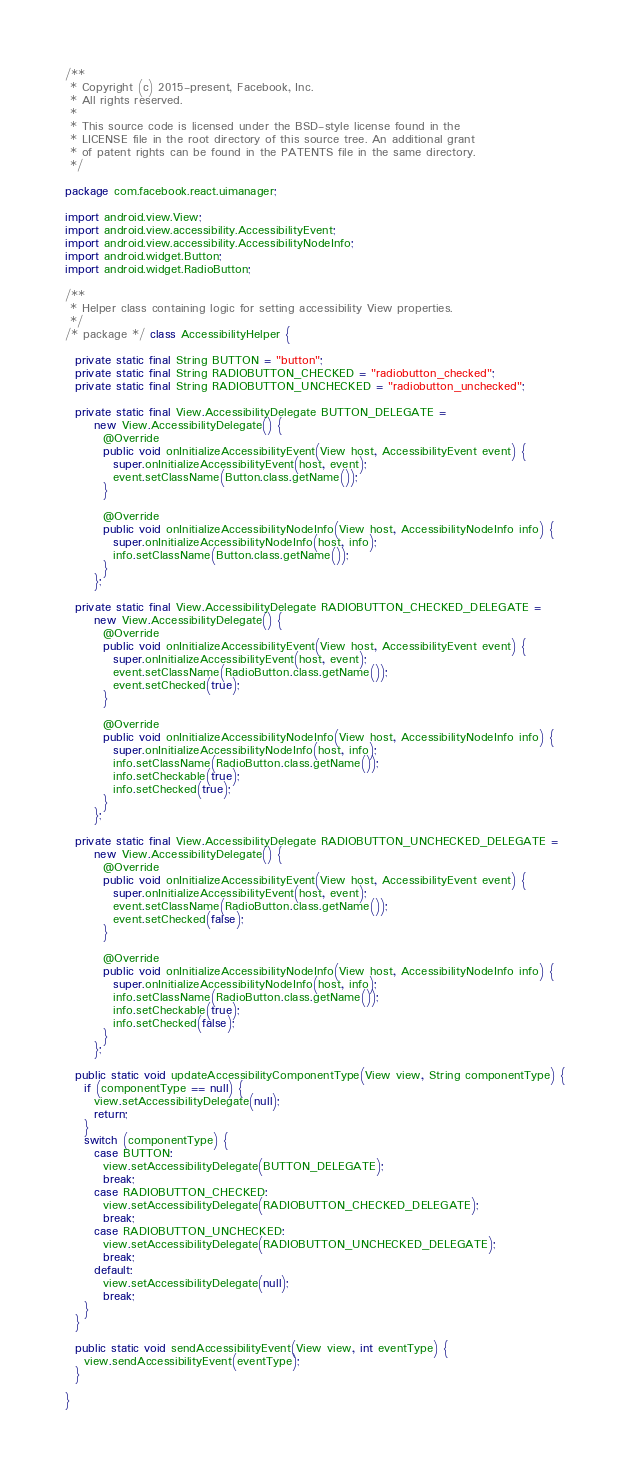<code> <loc_0><loc_0><loc_500><loc_500><_Java_>/**
 * Copyright (c) 2015-present, Facebook, Inc.
 * All rights reserved.
 *
 * This source code is licensed under the BSD-style license found in the
 * LICENSE file in the root directory of this source tree. An additional grant
 * of patent rights can be found in the PATENTS file in the same directory.
 */

package com.facebook.react.uimanager;

import android.view.View;
import android.view.accessibility.AccessibilityEvent;
import android.view.accessibility.AccessibilityNodeInfo;
import android.widget.Button;
import android.widget.RadioButton;

/**
 * Helper class containing logic for setting accessibility View properties.
 */
/* package */ class AccessibilityHelper {

  private static final String BUTTON = "button";
  private static final String RADIOBUTTON_CHECKED = "radiobutton_checked";
  private static final String RADIOBUTTON_UNCHECKED = "radiobutton_unchecked";

  private static final View.AccessibilityDelegate BUTTON_DELEGATE =
      new View.AccessibilityDelegate() {
        @Override
        public void onInitializeAccessibilityEvent(View host, AccessibilityEvent event) {
          super.onInitializeAccessibilityEvent(host, event);
          event.setClassName(Button.class.getName());
        }

        @Override
        public void onInitializeAccessibilityNodeInfo(View host, AccessibilityNodeInfo info) {
          super.onInitializeAccessibilityNodeInfo(host, info);
          info.setClassName(Button.class.getName());
        }
      };

  private static final View.AccessibilityDelegate RADIOBUTTON_CHECKED_DELEGATE =
      new View.AccessibilityDelegate() {
        @Override
        public void onInitializeAccessibilityEvent(View host, AccessibilityEvent event) {
          super.onInitializeAccessibilityEvent(host, event);
          event.setClassName(RadioButton.class.getName());
          event.setChecked(true);
        }

        @Override
        public void onInitializeAccessibilityNodeInfo(View host, AccessibilityNodeInfo info) {
          super.onInitializeAccessibilityNodeInfo(host, info);
          info.setClassName(RadioButton.class.getName());
          info.setCheckable(true);
          info.setChecked(true);
        }
      };

  private static final View.AccessibilityDelegate RADIOBUTTON_UNCHECKED_DELEGATE =
      new View.AccessibilityDelegate() {
        @Override
        public void onInitializeAccessibilityEvent(View host, AccessibilityEvent event) {
          super.onInitializeAccessibilityEvent(host, event);
          event.setClassName(RadioButton.class.getName());
          event.setChecked(false);
        }

        @Override
        public void onInitializeAccessibilityNodeInfo(View host, AccessibilityNodeInfo info) {
          super.onInitializeAccessibilityNodeInfo(host, info);
          info.setClassName(RadioButton.class.getName());
          info.setCheckable(true);
          info.setChecked(false);
        }
      };

  public static void updateAccessibilityComponentType(View view, String componentType) {
    if (componentType == null) {
      view.setAccessibilityDelegate(null);
      return;
    }
    switch (componentType) {
      case BUTTON:
        view.setAccessibilityDelegate(BUTTON_DELEGATE);
        break;
      case RADIOBUTTON_CHECKED:
        view.setAccessibilityDelegate(RADIOBUTTON_CHECKED_DELEGATE);
        break;
      case RADIOBUTTON_UNCHECKED:
        view.setAccessibilityDelegate(RADIOBUTTON_UNCHECKED_DELEGATE);
        break;
      default:
        view.setAccessibilityDelegate(null);
        break;
    }
  }

  public static void sendAccessibilityEvent(View view, int eventType) {
    view.sendAccessibilityEvent(eventType);
  }

}
</code> 